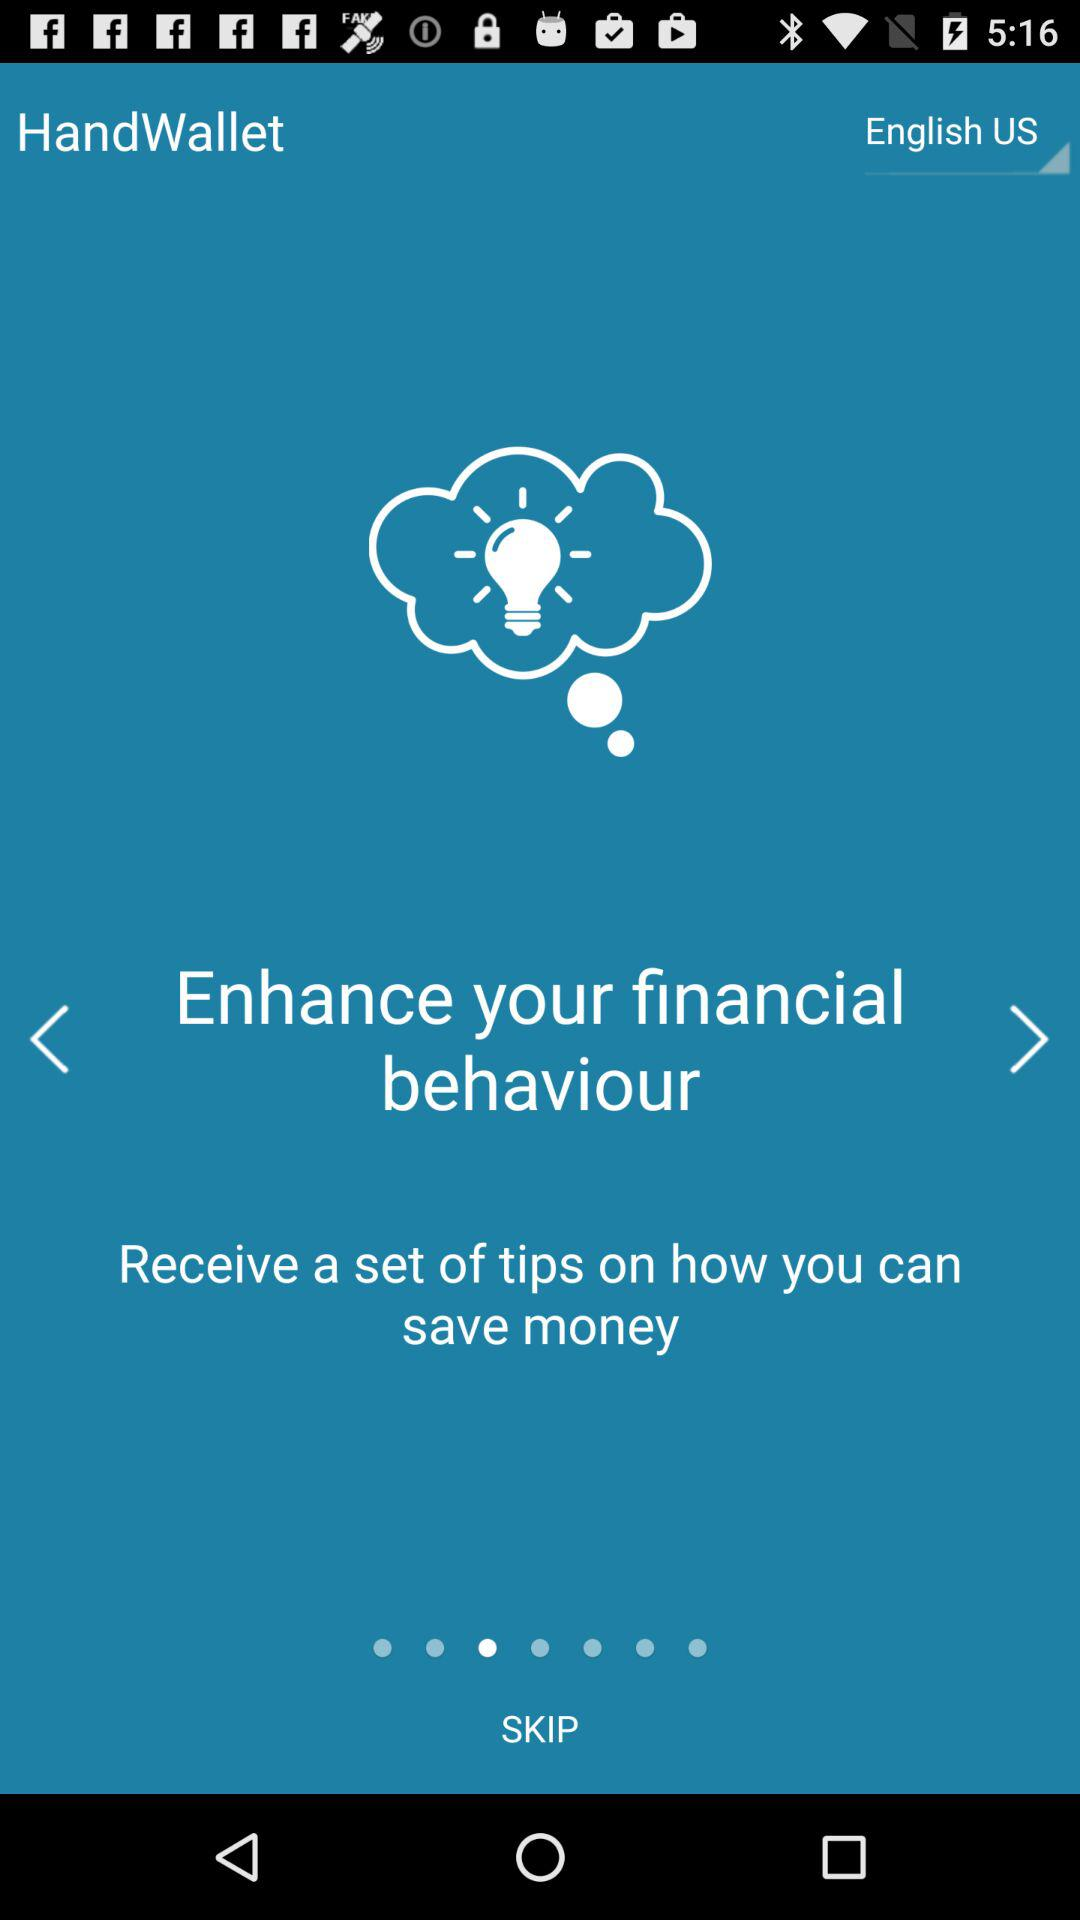Which language is selected? The selected language is English (US). 